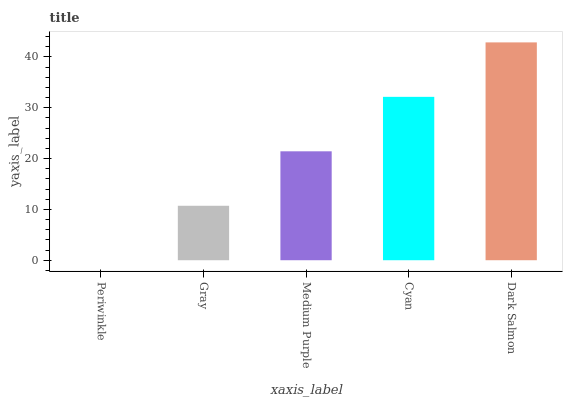Is Periwinkle the minimum?
Answer yes or no. Yes. Is Dark Salmon the maximum?
Answer yes or no. Yes. Is Gray the minimum?
Answer yes or no. No. Is Gray the maximum?
Answer yes or no. No. Is Gray greater than Periwinkle?
Answer yes or no. Yes. Is Periwinkle less than Gray?
Answer yes or no. Yes. Is Periwinkle greater than Gray?
Answer yes or no. No. Is Gray less than Periwinkle?
Answer yes or no. No. Is Medium Purple the high median?
Answer yes or no. Yes. Is Medium Purple the low median?
Answer yes or no. Yes. Is Gray the high median?
Answer yes or no. No. Is Dark Salmon the low median?
Answer yes or no. No. 